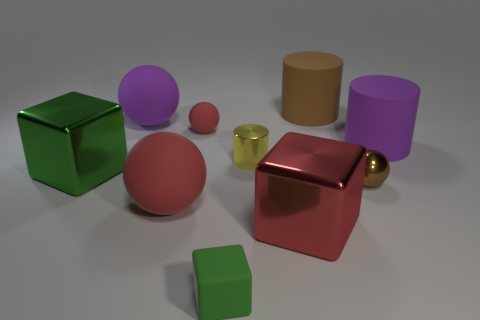What is the size of the metallic object that is the same color as the tiny matte ball?
Your response must be concise. Large. There is a large metallic thing that is the same color as the matte cube; what shape is it?
Offer a terse response. Cube. What material is the tiny sphere in front of the yellow cylinder?
Your answer should be compact. Metal. What size is the red block?
Make the answer very short. Large. Is the material of the purple cylinder that is behind the large red matte thing the same as the tiny brown thing?
Your answer should be compact. No. How many large red objects are there?
Provide a short and direct response. 2. What number of things are either tiny purple matte cylinders or large red matte things?
Ensure brevity in your answer.  1. What number of tiny green cubes are left of the rubber cylinder that is to the right of the large rubber cylinder on the left side of the metallic sphere?
Give a very brief answer. 1. Is there anything else that has the same color as the tiny shiny sphere?
Offer a very short reply. Yes. Do the large rubber cylinder left of the purple cylinder and the small object in front of the tiny metal ball have the same color?
Provide a succinct answer. No. 